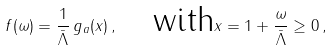<formula> <loc_0><loc_0><loc_500><loc_500>f ( \omega ) = \frac { 1 } { \bar { \Lambda } } \, g _ { a } ( x ) \, , \quad \text {with} x = 1 + \frac { \omega } { \bar { \Lambda } } \geq 0 \, ,</formula> 